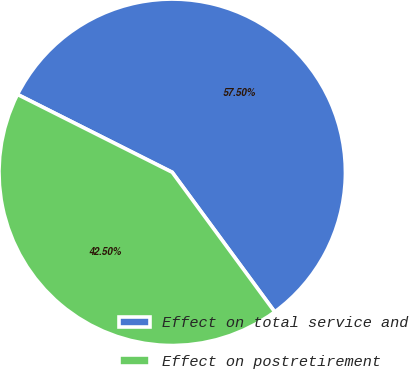Convert chart. <chart><loc_0><loc_0><loc_500><loc_500><pie_chart><fcel>Effect on total service and<fcel>Effect on postretirement<nl><fcel>57.5%<fcel>42.5%<nl></chart> 